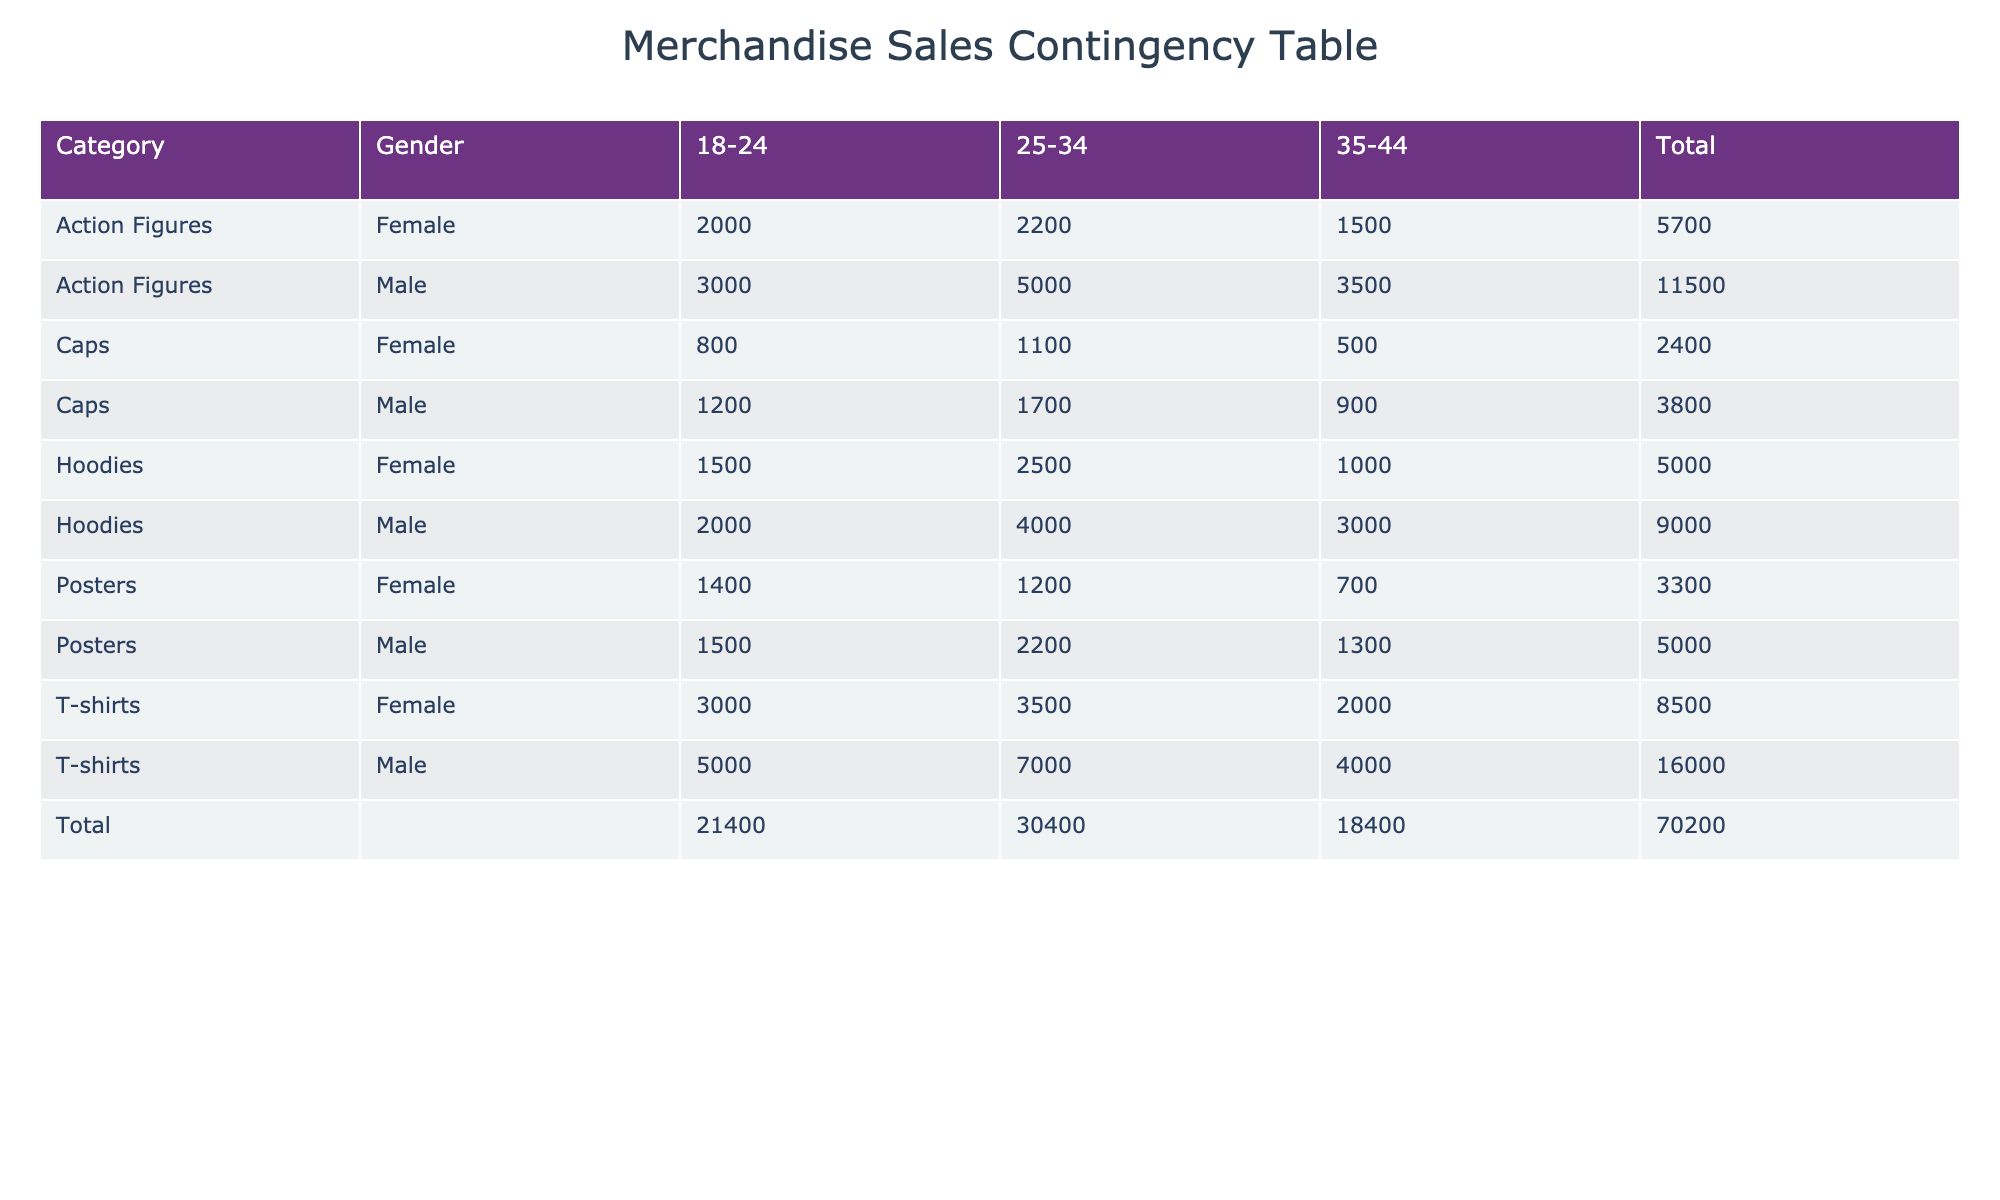What is the total sales for T-shirts among females aged 25-34? From the table, the sales for T-shirts among females aged 25-34 is listed as 3500.
Answer: 3500 Which category had the highest total sales for males in the age group 18-24? Looking at the sales for males aged 18-24, T-shirts had sales of 5000, Hoodies had 2000, Caps had 1200, Posters had 1500, and Action Figures had 3000. The highest sales were T-shirts at 5000.
Answer: T-shirts Is the total sales for caps greater than the total sales for posters? The total sales for Caps can be calculated: 1200 + 1700 + 900 = 3800. For Posters, total sales are: 1500 + 2200 + 1300 = 5000. Since 3800 is not greater than 5000, the answer is no.
Answer: No What is the difference in total sales between females and males in the age group 25-34 for Hoodies? For 25-34 age group Hoodies, males total sales are 4000 and females are 2500. The difference is 4000 - 2500 = 1500.
Answer: 1500 Which age group contributes the least to the overall sales for Action Figures? For Action Figures, the sales by age group are: 18-24 (5000), 25-34 (2200), and 35-44 (1500). The least contribution comes from the age group 35-44 with sales of 1500.
Answer: 35-44 